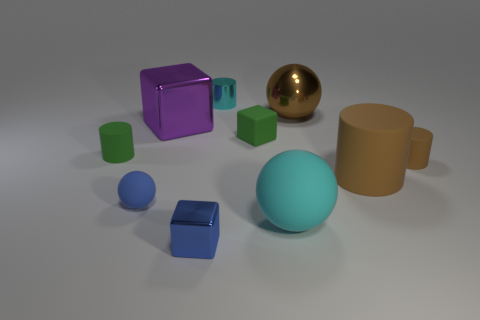There is a big matte object that is the same color as the tiny metal cylinder; what is its shape?
Your answer should be compact. Sphere. Are there any other spheres made of the same material as the cyan sphere?
Make the answer very short. Yes. The metallic object that is the same color as the big rubber cylinder is what size?
Offer a terse response. Large. What number of spheres are either large brown rubber things or small cyan matte things?
Ensure brevity in your answer.  0. The cyan metal cylinder is what size?
Provide a short and direct response. Small. There is a big purple cube; what number of blue balls are in front of it?
Provide a short and direct response. 1. How big is the sphere that is behind the cylinder left of the small cyan metallic thing?
Make the answer very short. Large. There is a small green matte thing that is to the left of the small ball; does it have the same shape as the tiny brown rubber object on the right side of the tiny blue block?
Your response must be concise. Yes. What shape is the small green thing that is to the left of the cyan object behind the green cylinder?
Provide a short and direct response. Cylinder. What is the size of the object that is both in front of the small blue matte sphere and to the left of the cyan cylinder?
Offer a very short reply. Small. 